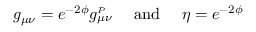Convert formula to latex. <formula><loc_0><loc_0><loc_500><loc_500>g _ { \mu \nu } = e ^ { - 2 \phi } g _ { \mu \nu } ^ { _ { P } } \quad a n d \quad \eta = e ^ { - 2 \phi }</formula> 